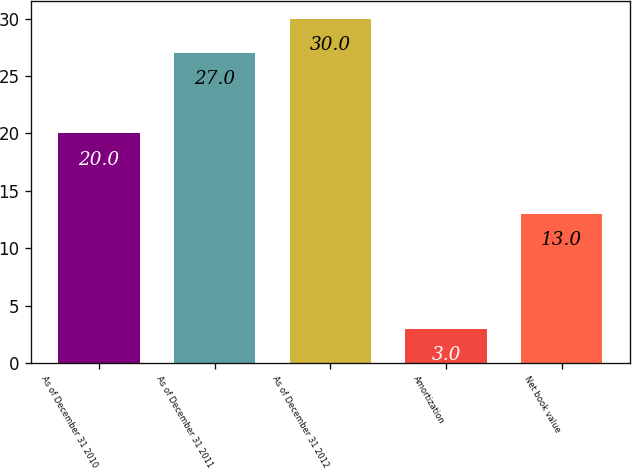Convert chart to OTSL. <chart><loc_0><loc_0><loc_500><loc_500><bar_chart><fcel>As of December 31 2010<fcel>As of December 31 2011<fcel>As of December 31 2012<fcel>Amortization<fcel>Net book value<nl><fcel>20<fcel>27<fcel>30<fcel>3<fcel>13<nl></chart> 